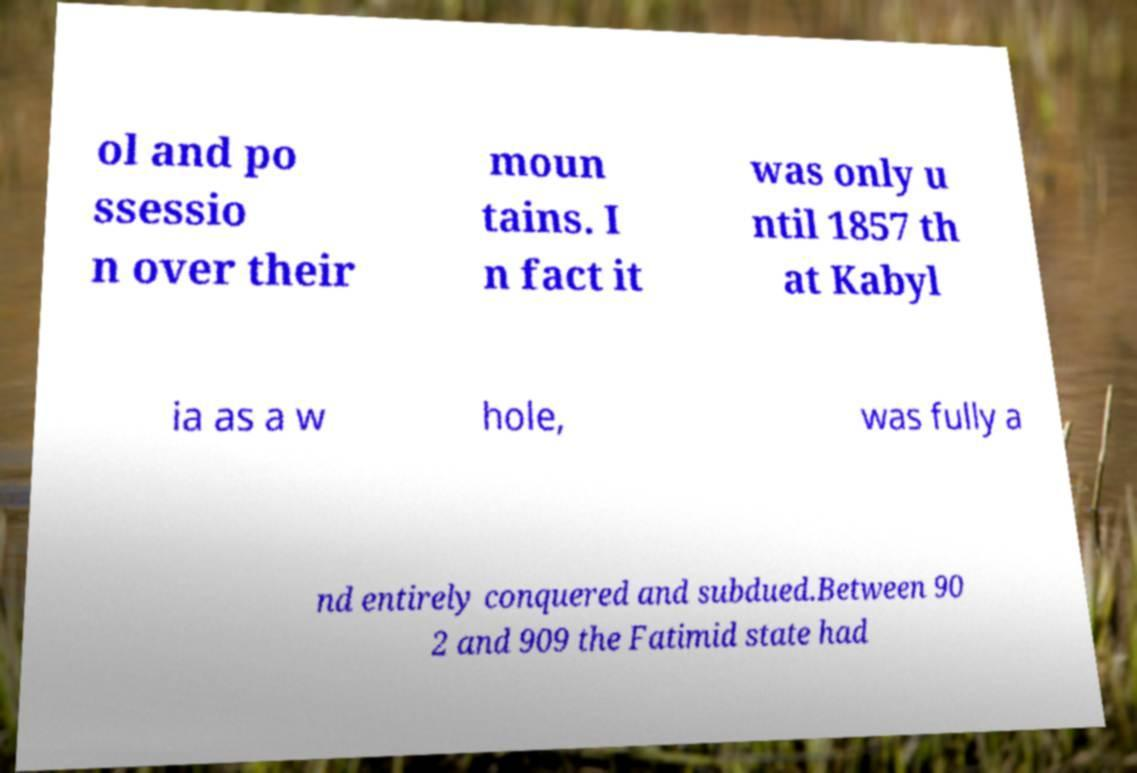Please read and relay the text visible in this image. What does it say? ol and po ssessio n over their moun tains. I n fact it was only u ntil 1857 th at Kabyl ia as a w hole, was fully a nd entirely conquered and subdued.Between 90 2 and 909 the Fatimid state had 